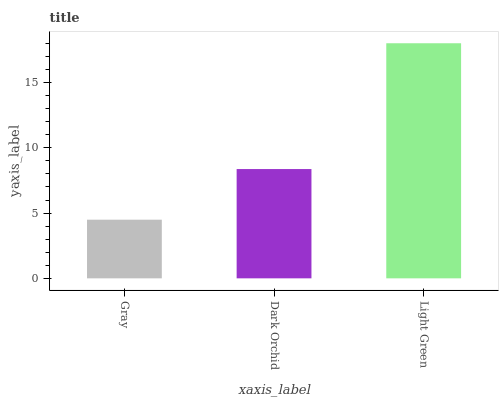Is Gray the minimum?
Answer yes or no. Yes. Is Light Green the maximum?
Answer yes or no. Yes. Is Dark Orchid the minimum?
Answer yes or no. No. Is Dark Orchid the maximum?
Answer yes or no. No. Is Dark Orchid greater than Gray?
Answer yes or no. Yes. Is Gray less than Dark Orchid?
Answer yes or no. Yes. Is Gray greater than Dark Orchid?
Answer yes or no. No. Is Dark Orchid less than Gray?
Answer yes or no. No. Is Dark Orchid the high median?
Answer yes or no. Yes. Is Dark Orchid the low median?
Answer yes or no. Yes. Is Gray the high median?
Answer yes or no. No. Is Light Green the low median?
Answer yes or no. No. 